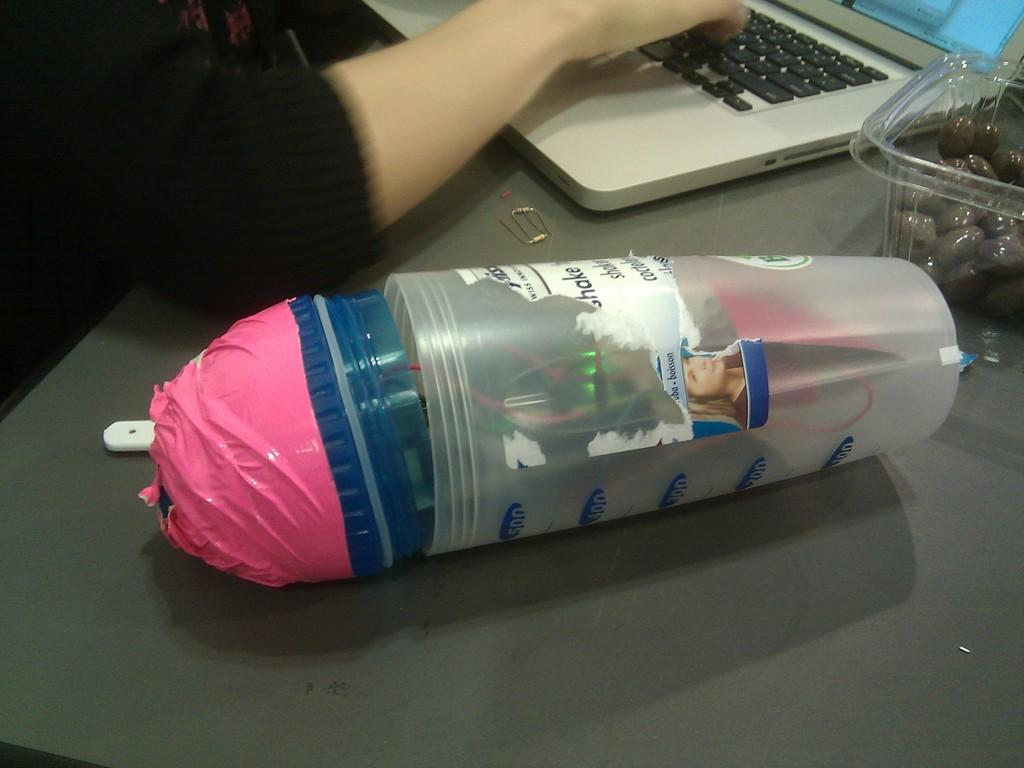<image>
Give a short and clear explanation of the subsequent image. A clutter filled measuring cup with the top number saying 500 